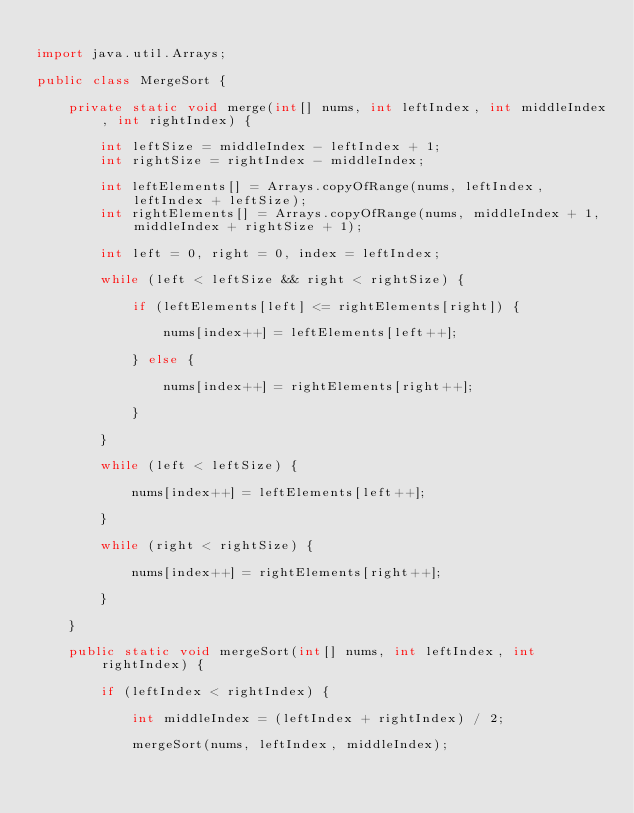Convert code to text. <code><loc_0><loc_0><loc_500><loc_500><_Java_>
import java.util.Arrays;

public class MergeSort {

    private static void merge(int[] nums, int leftIndex, int middleIndex, int rightIndex) {

        int leftSize = middleIndex - leftIndex + 1;
        int rightSize = rightIndex - middleIndex;

        int leftElements[] = Arrays.copyOfRange(nums, leftIndex, leftIndex + leftSize);
        int rightElements[] = Arrays.copyOfRange(nums, middleIndex + 1, middleIndex + rightSize + 1);

        int left = 0, right = 0, index = leftIndex;

        while (left < leftSize && right < rightSize) {

            if (leftElements[left] <= rightElements[right]) {

                nums[index++] = leftElements[left++];

            } else {

                nums[index++] = rightElements[right++];

            }

        }

        while (left < leftSize) {

            nums[index++] = leftElements[left++];

        }

        while (right < rightSize) {

            nums[index++] = rightElements[right++];

        }

    }

    public static void mergeSort(int[] nums, int leftIndex, int rightIndex) {

        if (leftIndex < rightIndex) {

            int middleIndex = (leftIndex + rightIndex) / 2;

            mergeSort(nums, leftIndex, middleIndex);</code> 